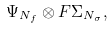Convert formula to latex. <formula><loc_0><loc_0><loc_500><loc_500>\Psi _ { N _ { f } } \otimes F \Sigma _ { N _ { \sigma } } ,</formula> 